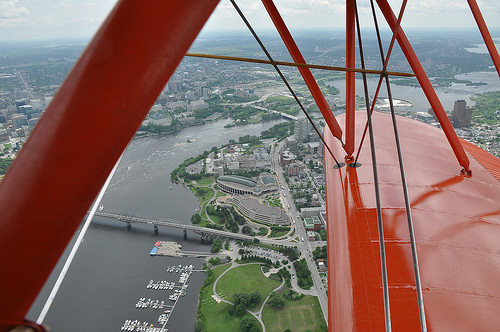<image>
Can you confirm if the sky is behind the building? No. The sky is not behind the building. From this viewpoint, the sky appears to be positioned elsewhere in the scene. 